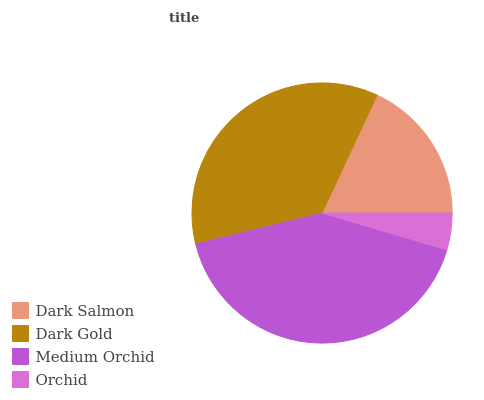Is Orchid the minimum?
Answer yes or no. Yes. Is Medium Orchid the maximum?
Answer yes or no. Yes. Is Dark Gold the minimum?
Answer yes or no. No. Is Dark Gold the maximum?
Answer yes or no. No. Is Dark Gold greater than Dark Salmon?
Answer yes or no. Yes. Is Dark Salmon less than Dark Gold?
Answer yes or no. Yes. Is Dark Salmon greater than Dark Gold?
Answer yes or no. No. Is Dark Gold less than Dark Salmon?
Answer yes or no. No. Is Dark Gold the high median?
Answer yes or no. Yes. Is Dark Salmon the low median?
Answer yes or no. Yes. Is Orchid the high median?
Answer yes or no. No. Is Orchid the low median?
Answer yes or no. No. 